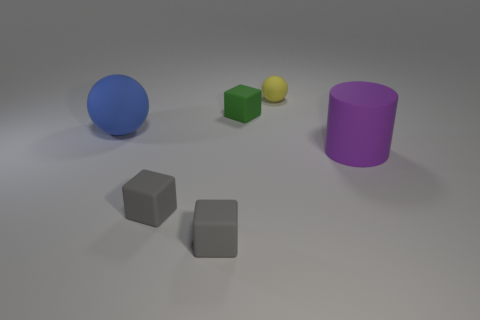Add 4 matte cubes. How many objects exist? 10 Subtract all spheres. How many objects are left? 4 Subtract all large blue rubber things. Subtract all large things. How many objects are left? 3 Add 4 green rubber cubes. How many green rubber cubes are left? 5 Add 5 green cylinders. How many green cylinders exist? 5 Subtract 0 red cylinders. How many objects are left? 6 